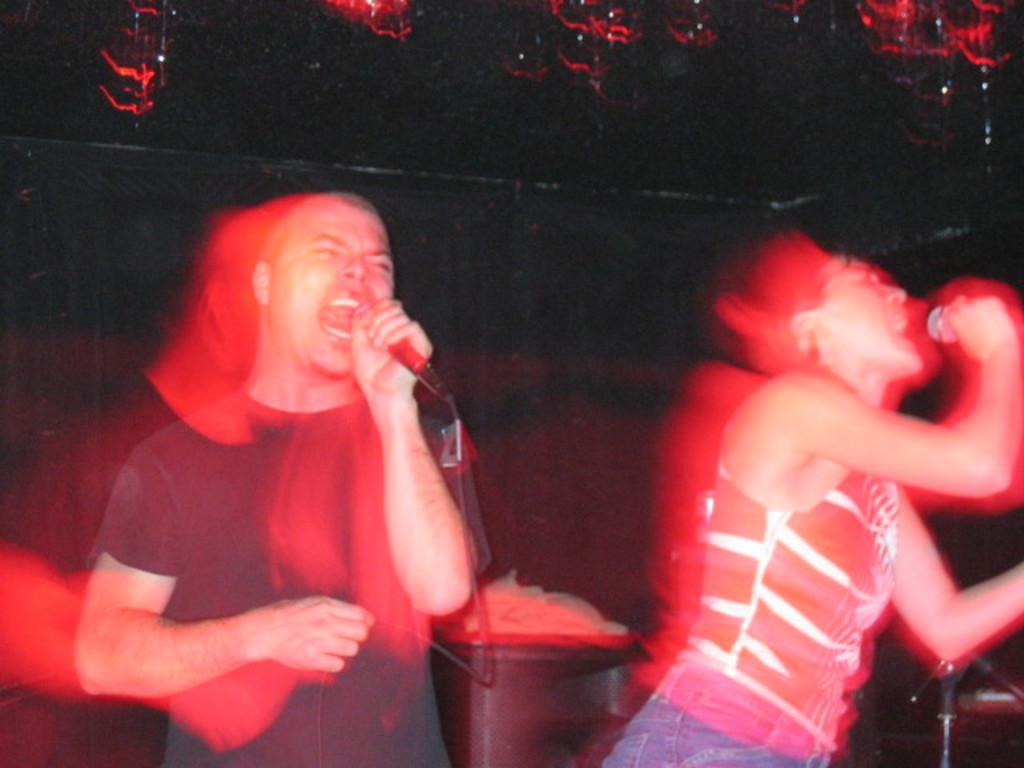Can you describe this image briefly? On the left side, there is a person in a t-shirt, holding a microphone with a hand singing. On the right side, there is a woman in a t-shirt, holding a microphone with a hand and singing. In the background, there are other objects. And the background is dark in color. 